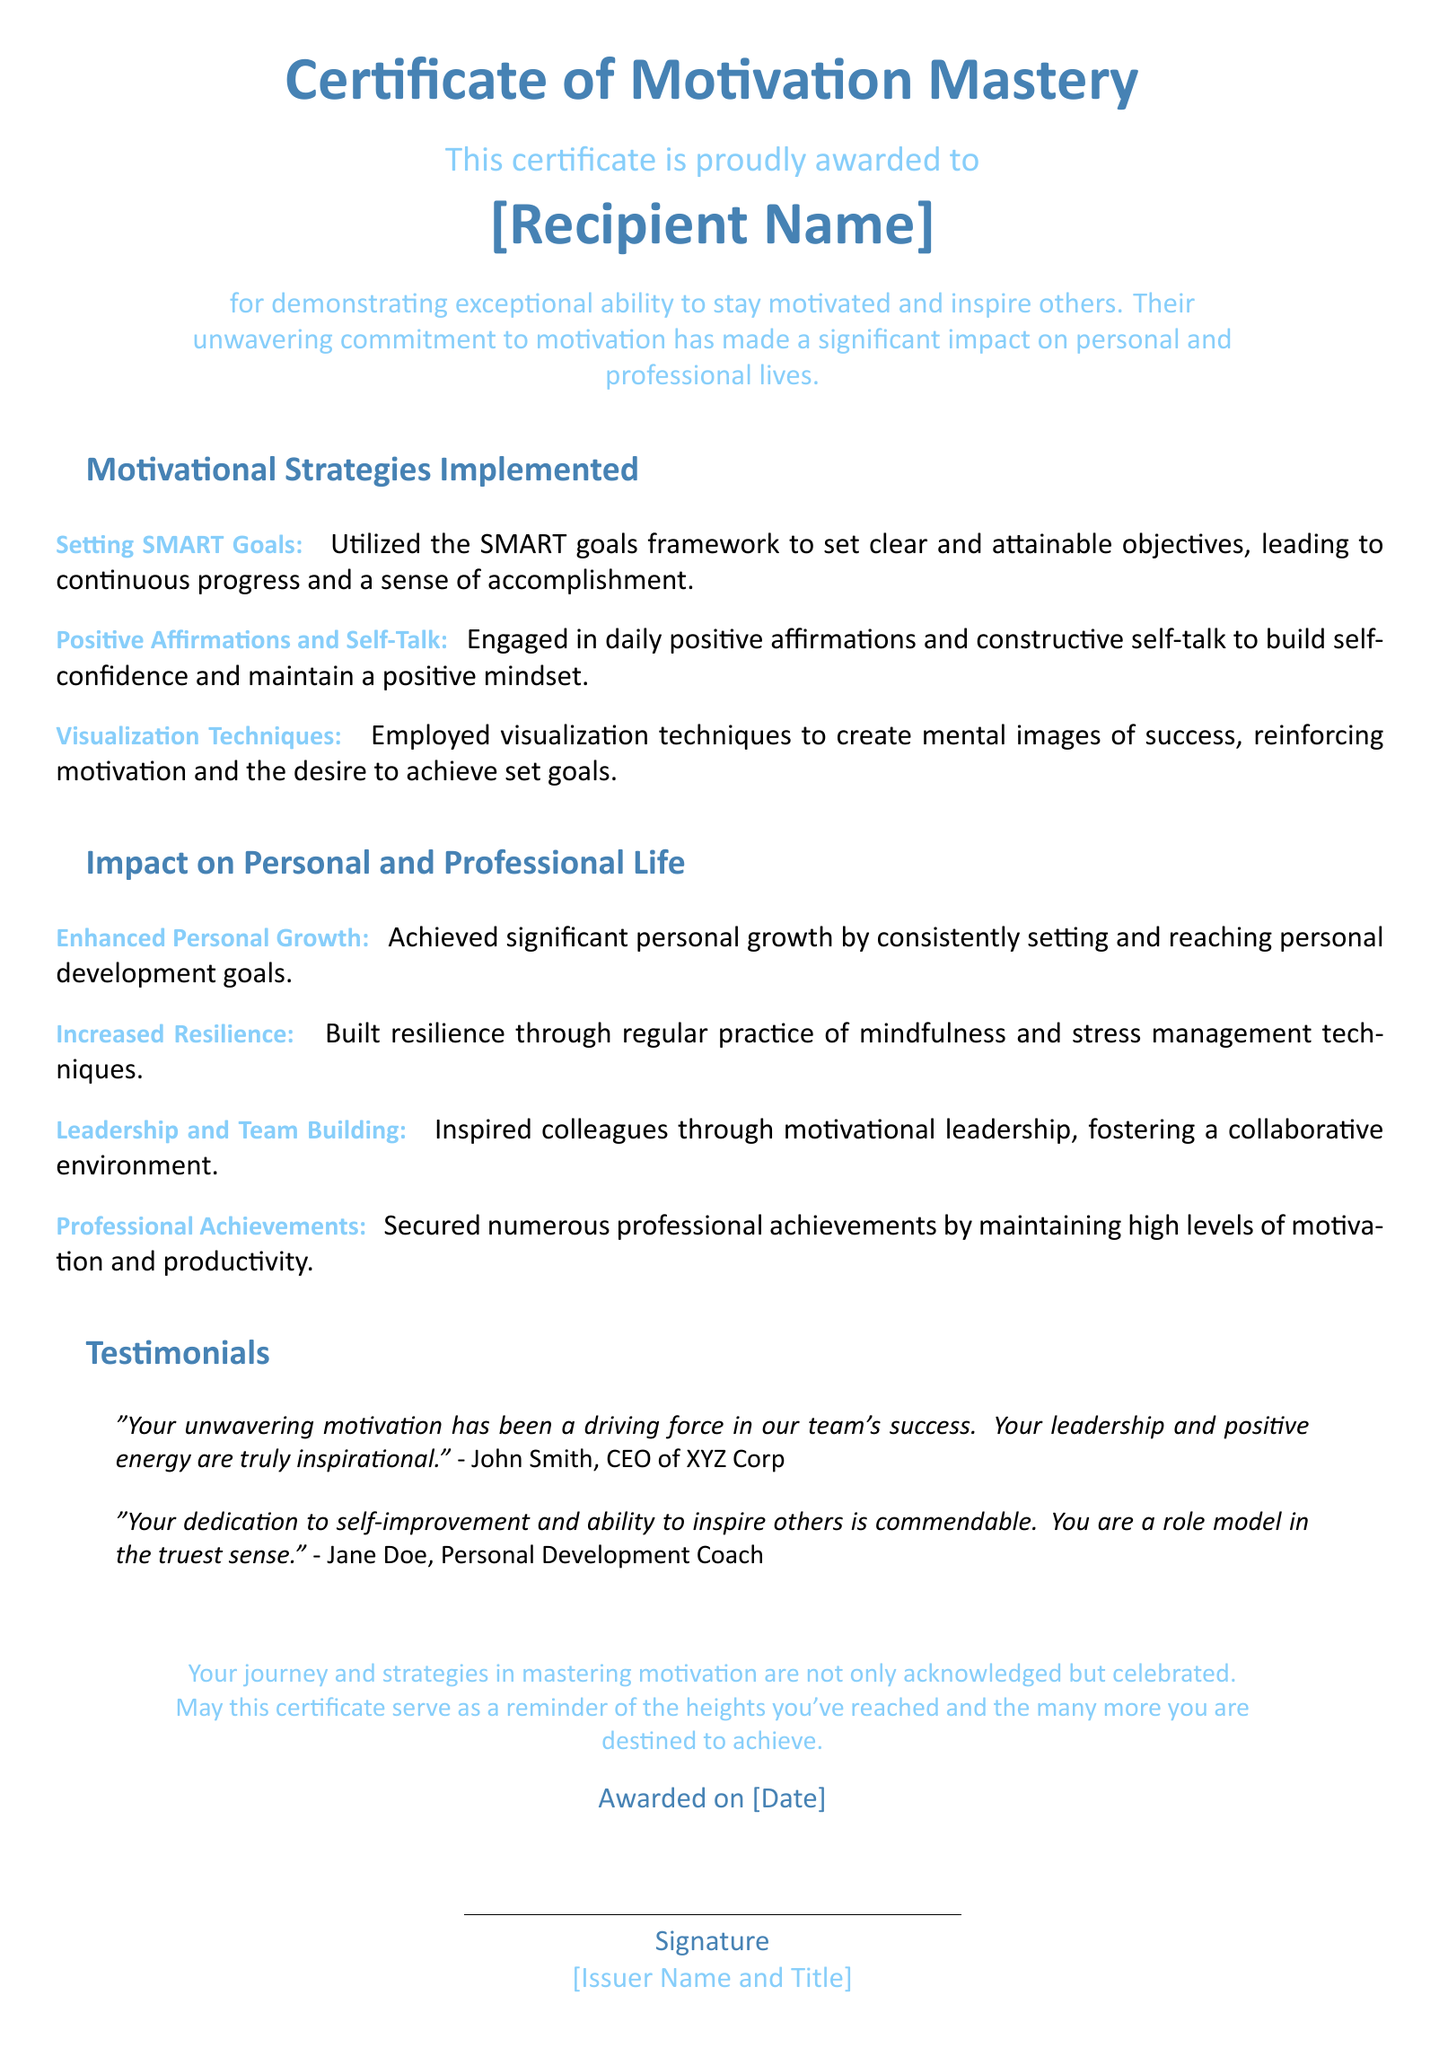What is the title of the certificate? The title of the certificate is a prominent heading at the top of the document.
Answer: Certificate of Motivation Mastery Who is the certificate awarded to? The recipient's name is indicated prominently in the document.
Answer: [Recipient Name] What is the main purpose of this certificate? The document provides a description of the reasons for the award, indicating the recipient's abilities.
Answer: Demonstrating exceptional ability to stay motivated and inspire others What is one motivational strategy listed? The document outlines several strategies used by the recipient.
Answer: Setting SMART Goals What professional achievement is highlighted? The document mentions accomplishments related to professional life due to motivation.
Answer: Secured numerous professional achievements Who provided a testimonial about the recipient? Testimonials included in the document are from specific individuals.
Answer: John Smith On what date is the certificate awarded? The date is specified toward the end of the document.
Answer: [Date] What color theme is used in the certificate? The color scheme is mentioned through descriptions in the document.
Answer: Main color and second color Which skill demonstrates increased resilience according to the document? The document explains the strategies that contribute to personal growth and resilience.
Answer: Mindfulness and stress management techniques 